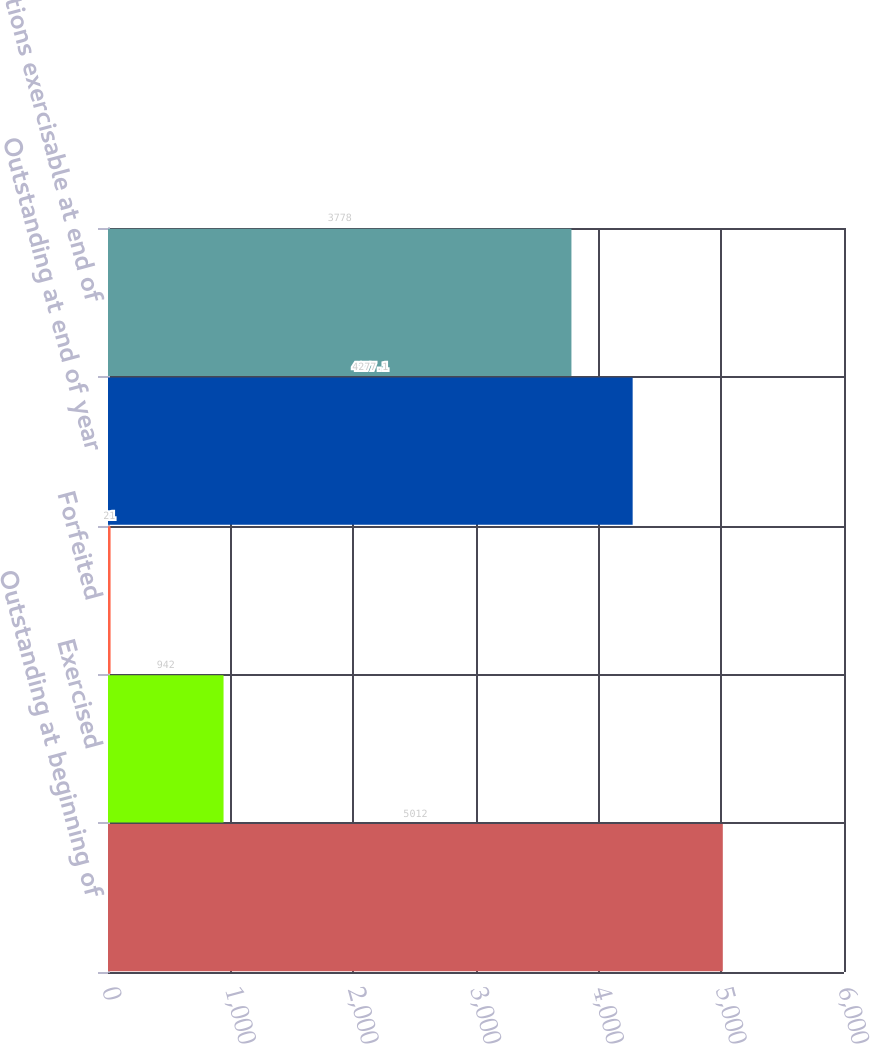<chart> <loc_0><loc_0><loc_500><loc_500><bar_chart><fcel>Outstanding at beginning of<fcel>Exercised<fcel>Forfeited<fcel>Outstanding at end of year<fcel>Options exercisable at end of<nl><fcel>5012<fcel>942<fcel>21<fcel>4277.1<fcel>3778<nl></chart> 